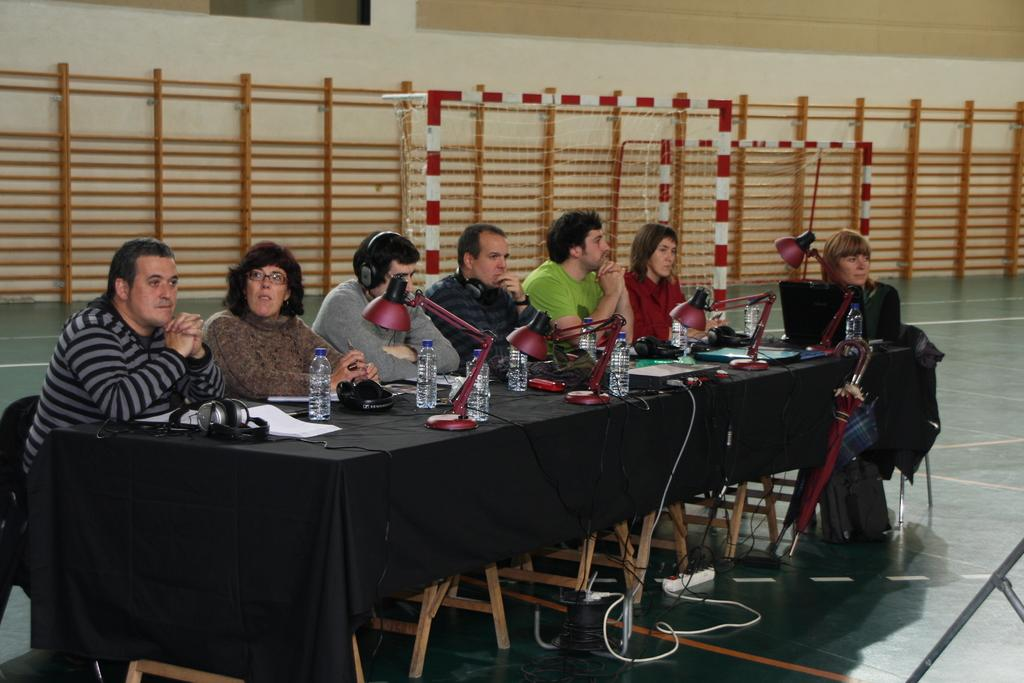How many people are in the image? There is a group of people in the image, but the exact number is not specified. What are the people doing in the image? The people are sitting in front of a table. What items can be seen on the table? There are water bottles, lights, and a headset on the table. What type of crime is being committed in the image? There is no indication of any crime being committed in the image. How many tomatoes are on the table in the image? There is no mention of tomatoes in the image. 